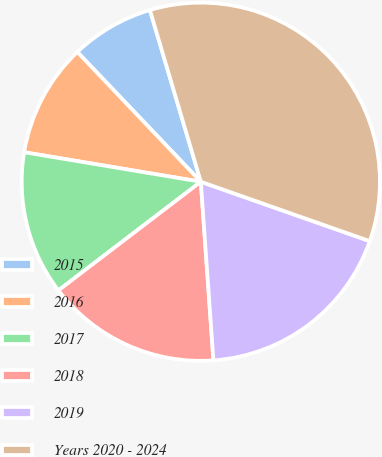Convert chart to OTSL. <chart><loc_0><loc_0><loc_500><loc_500><pie_chart><fcel>2015<fcel>2016<fcel>2017<fcel>2018<fcel>2019<fcel>Years 2020 - 2024<nl><fcel>7.52%<fcel>10.26%<fcel>13.01%<fcel>15.75%<fcel>18.5%<fcel>34.97%<nl></chart> 